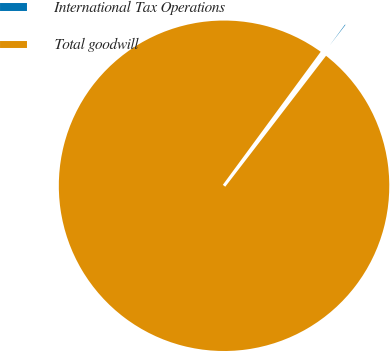<chart> <loc_0><loc_0><loc_500><loc_500><pie_chart><fcel>International Tax Operations<fcel>Total goodwill<nl><fcel>0.35%<fcel>99.65%<nl></chart> 